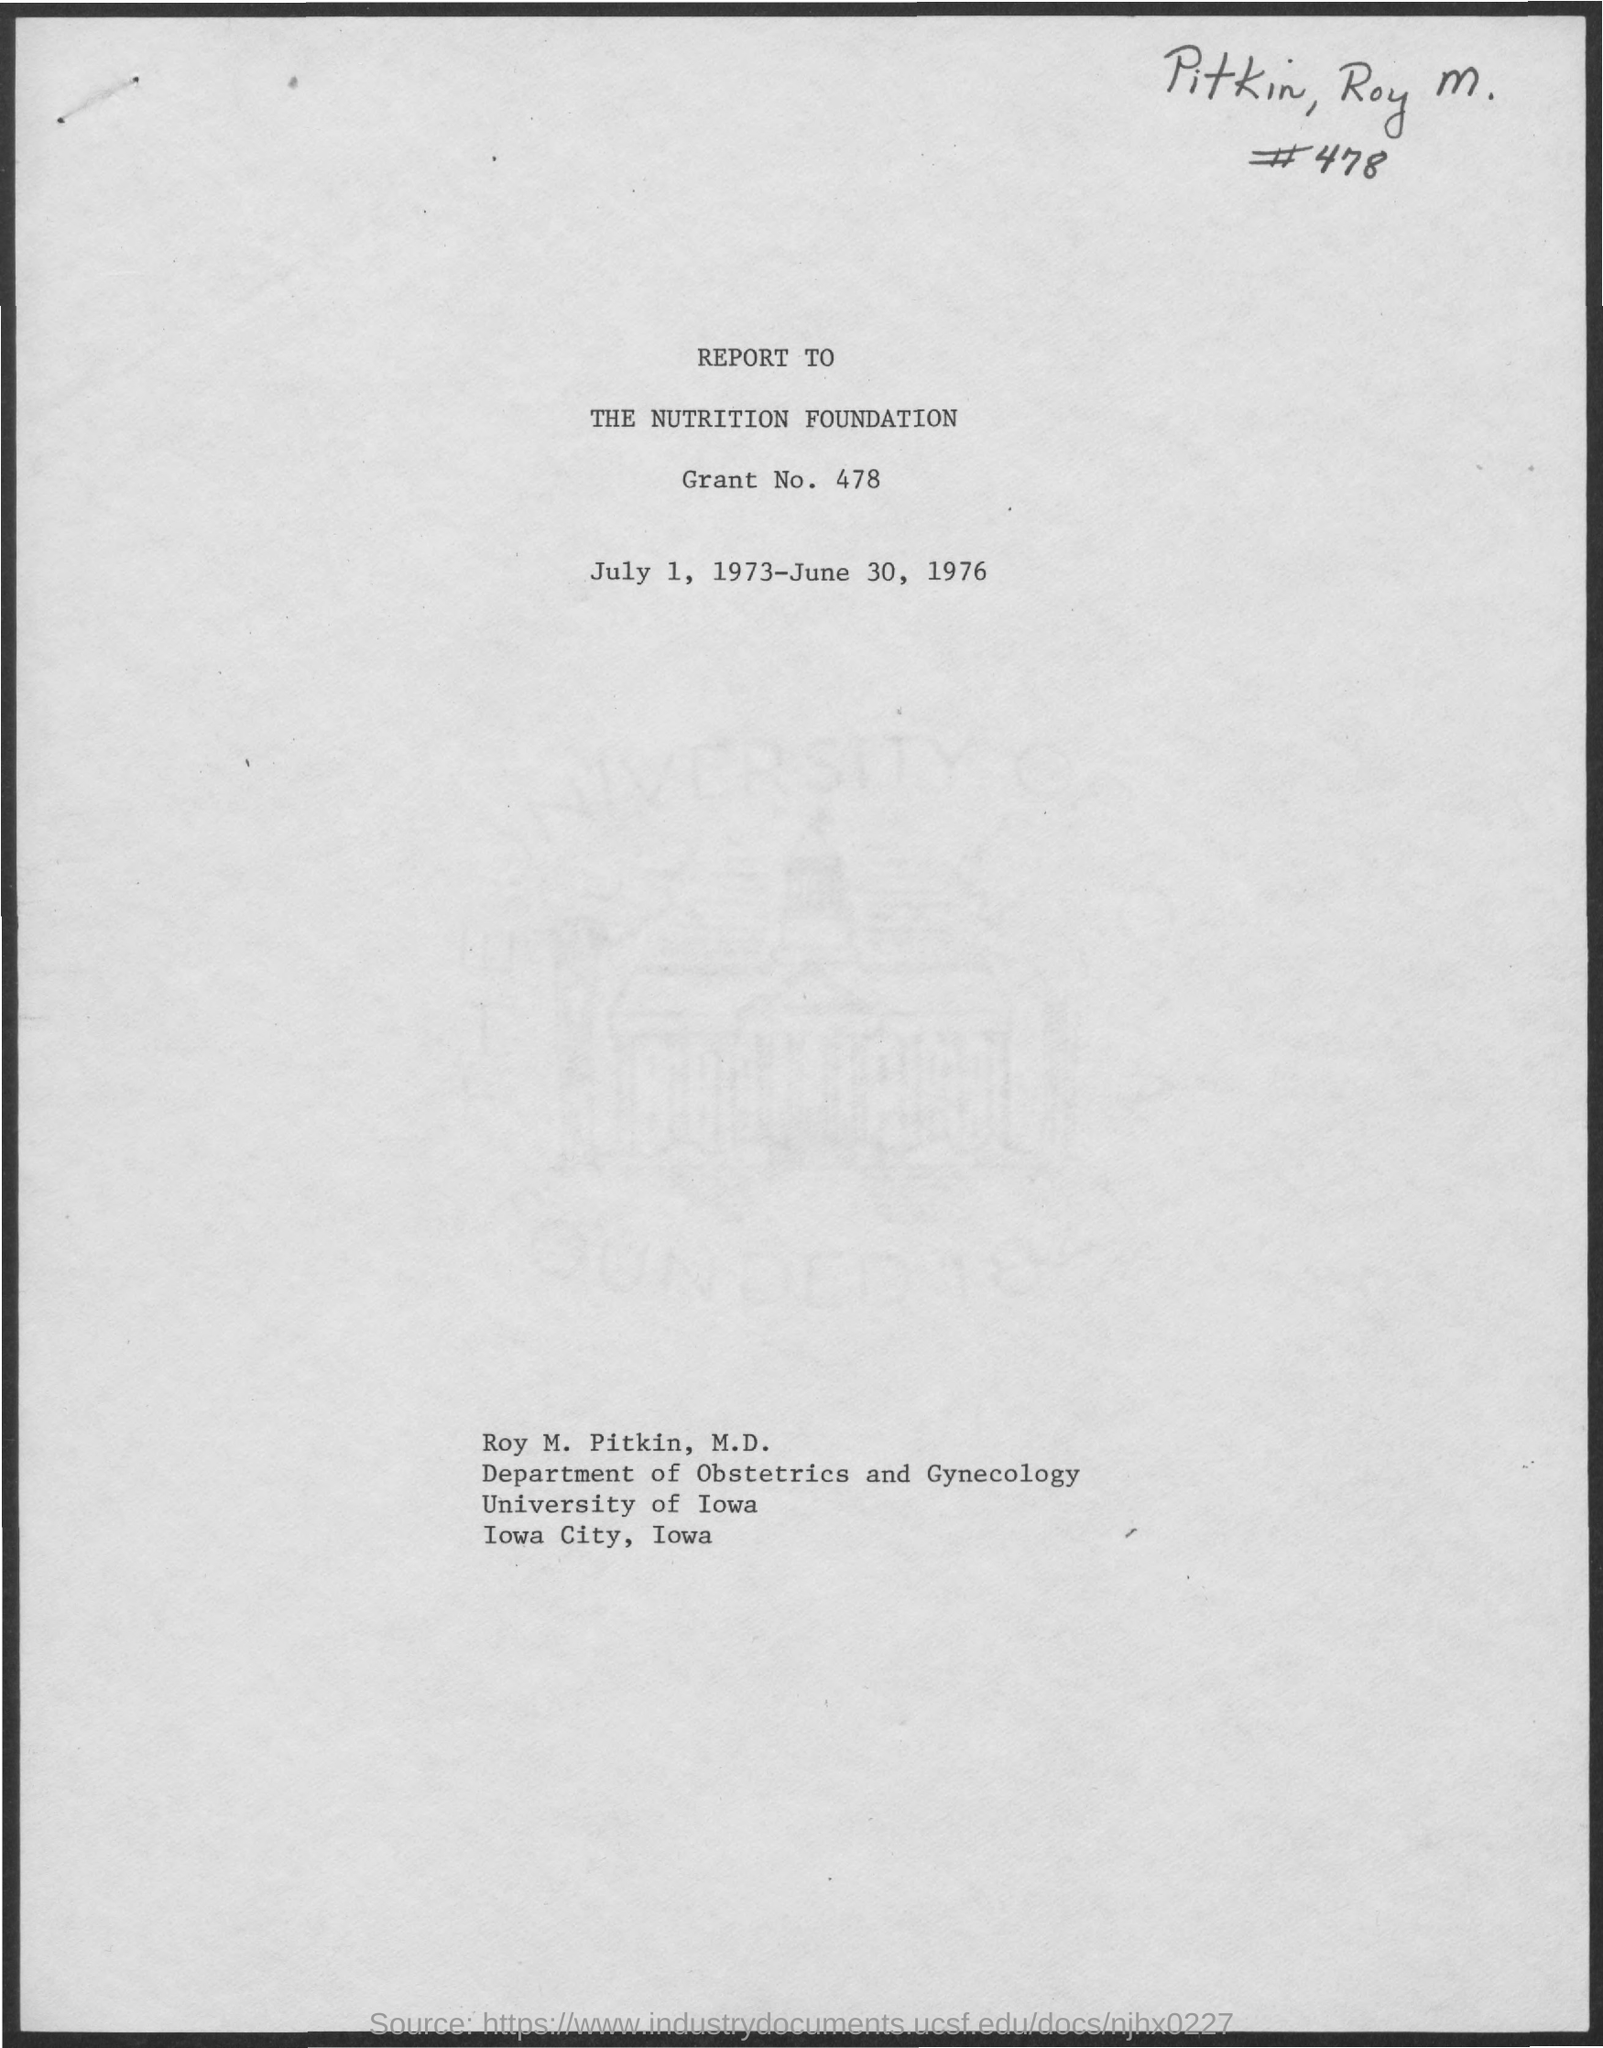What is the grant No.?
Provide a succinct answer. 478. When is the document dated?
Your response must be concise. July 1, 1973-June 30, 1976. Whose name is given?
Provide a succinct answer. Roy M. Pitkin. Which university is mentioned?
Give a very brief answer. University of Iowa. 